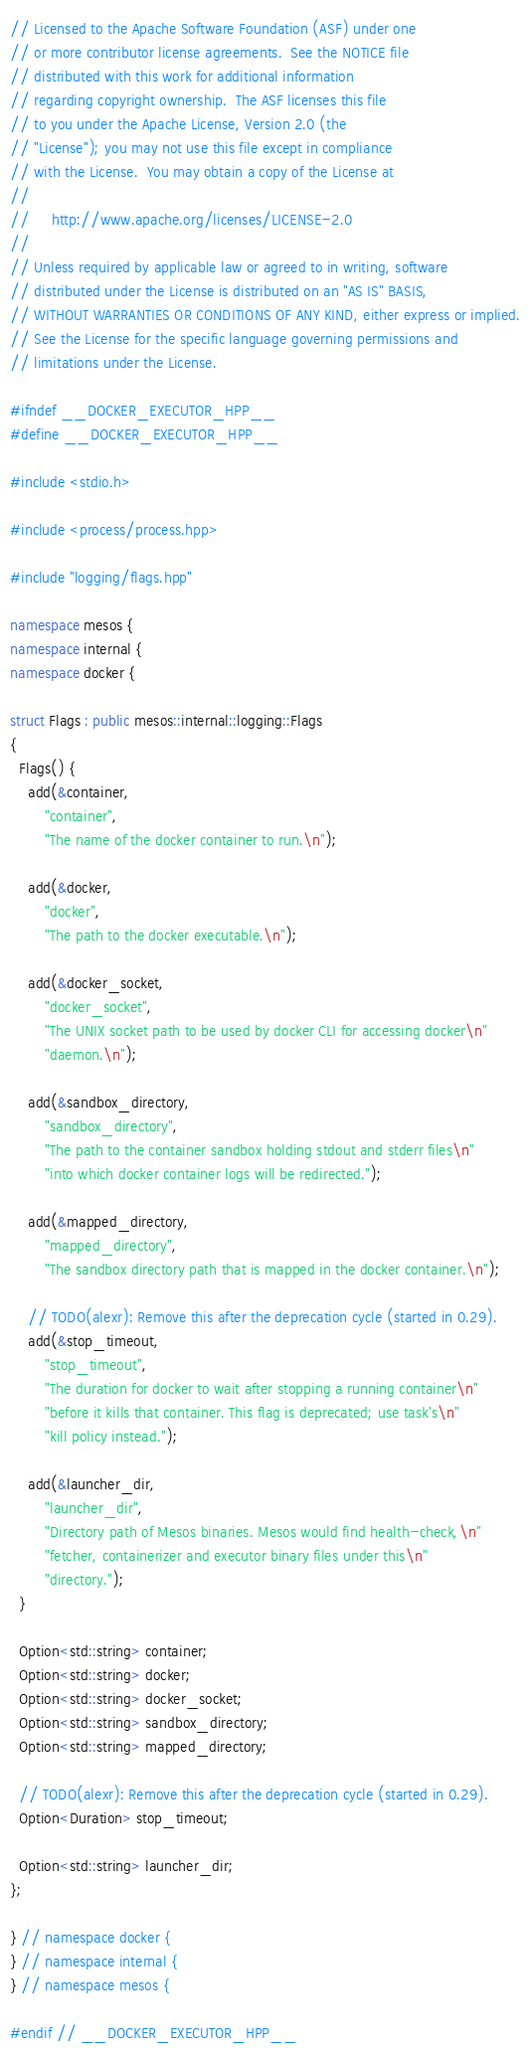Convert code to text. <code><loc_0><loc_0><loc_500><loc_500><_C++_>// Licensed to the Apache Software Foundation (ASF) under one
// or more contributor license agreements.  See the NOTICE file
// distributed with this work for additional information
// regarding copyright ownership.  The ASF licenses this file
// to you under the Apache License, Version 2.0 (the
// "License"); you may not use this file except in compliance
// with the License.  You may obtain a copy of the License at
//
//     http://www.apache.org/licenses/LICENSE-2.0
//
// Unless required by applicable law or agreed to in writing, software
// distributed under the License is distributed on an "AS IS" BASIS,
// WITHOUT WARRANTIES OR CONDITIONS OF ANY KIND, either express or implied.
// See the License for the specific language governing permissions and
// limitations under the License.

#ifndef __DOCKER_EXECUTOR_HPP__
#define __DOCKER_EXECUTOR_HPP__

#include <stdio.h>

#include <process/process.hpp>

#include "logging/flags.hpp"

namespace mesos {
namespace internal {
namespace docker {

struct Flags : public mesos::internal::logging::Flags
{
  Flags() {
    add(&container,
        "container",
        "The name of the docker container to run.\n");

    add(&docker,
        "docker",
        "The path to the docker executable.\n");

    add(&docker_socket,
        "docker_socket",
        "The UNIX socket path to be used by docker CLI for accessing docker\n"
        "daemon.\n");

    add(&sandbox_directory,
        "sandbox_directory",
        "The path to the container sandbox holding stdout and stderr files\n"
        "into which docker container logs will be redirected.");

    add(&mapped_directory,
        "mapped_directory",
        "The sandbox directory path that is mapped in the docker container.\n");

    // TODO(alexr): Remove this after the deprecation cycle (started in 0.29).
    add(&stop_timeout,
        "stop_timeout",
        "The duration for docker to wait after stopping a running container\n"
        "before it kills that container. This flag is deprecated; use task's\n"
        "kill policy instead.");

    add(&launcher_dir,
        "launcher_dir",
        "Directory path of Mesos binaries. Mesos would find health-check,\n"
        "fetcher, containerizer and executor binary files under this\n"
        "directory.");
  }

  Option<std::string> container;
  Option<std::string> docker;
  Option<std::string> docker_socket;
  Option<std::string> sandbox_directory;
  Option<std::string> mapped_directory;

  // TODO(alexr): Remove this after the deprecation cycle (started in 0.29).
  Option<Duration> stop_timeout;

  Option<std::string> launcher_dir;
};

} // namespace docker {
} // namespace internal {
} // namespace mesos {

#endif // __DOCKER_EXECUTOR_HPP__
</code> 